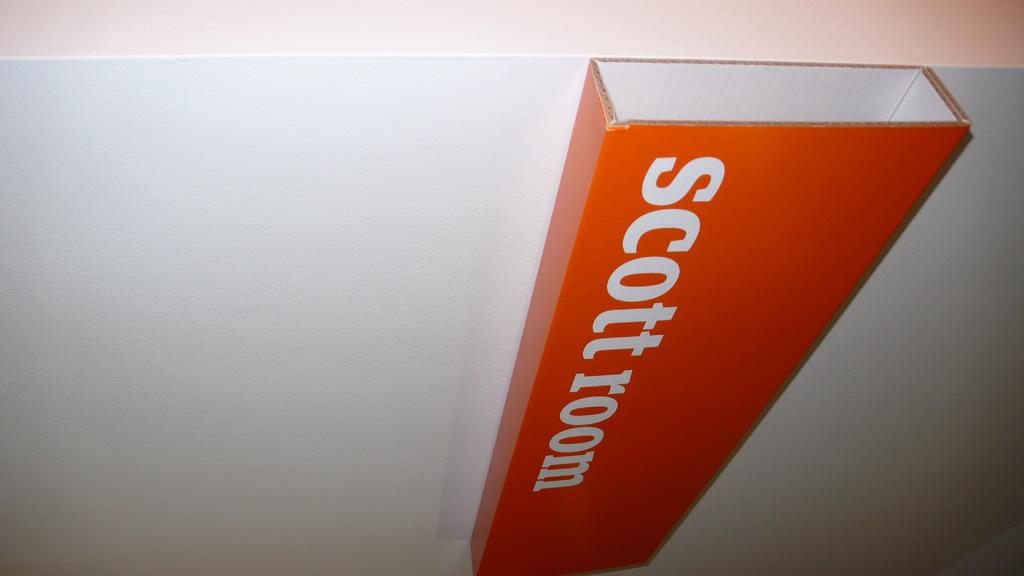<image>
Render a clear and concise summary of the photo. A rectangular box of cardboard reading Scott room is glued or otherwise attached to a white wall or piece of cardboard. 